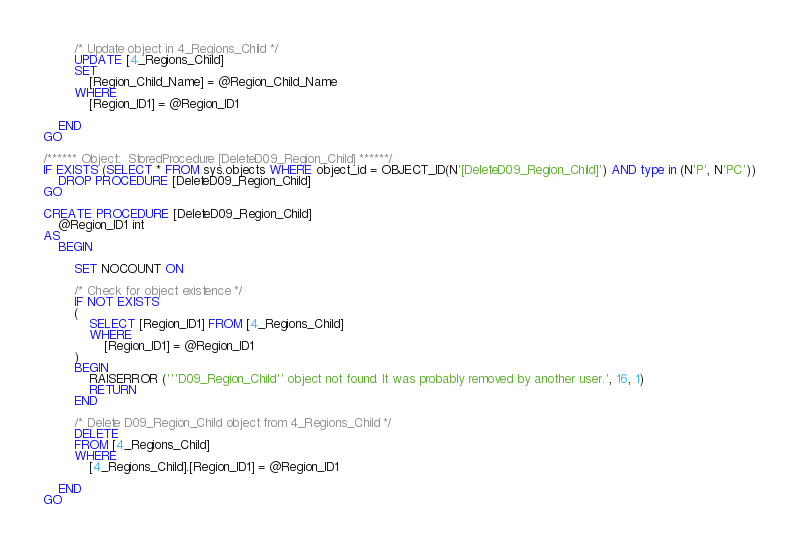Convert code to text. <code><loc_0><loc_0><loc_500><loc_500><_SQL_>        /* Update object in 4_Regions_Child */
        UPDATE [4_Regions_Child]
        SET
            [Region_Child_Name] = @Region_Child_Name
        WHERE
            [Region_ID1] = @Region_ID1

    END
GO

/****** Object:  StoredProcedure [DeleteD09_Region_Child] ******/
IF EXISTS (SELECT * FROM sys.objects WHERE object_id = OBJECT_ID(N'[DeleteD09_Region_Child]') AND type in (N'P', N'PC'))
    DROP PROCEDURE [DeleteD09_Region_Child]
GO

CREATE PROCEDURE [DeleteD09_Region_Child]
    @Region_ID1 int
AS
    BEGIN

        SET NOCOUNT ON

        /* Check for object existence */
        IF NOT EXISTS
        (
            SELECT [Region_ID1] FROM [4_Regions_Child]
            WHERE
                [Region_ID1] = @Region_ID1
        )
        BEGIN
            RAISERROR ('''D09_Region_Child'' object not found. It was probably removed by another user.', 16, 1)
            RETURN
        END

        /* Delete D09_Region_Child object from 4_Regions_Child */
        DELETE
        FROM [4_Regions_Child]
        WHERE
            [4_Regions_Child].[Region_ID1] = @Region_ID1

    END
GO
</code> 